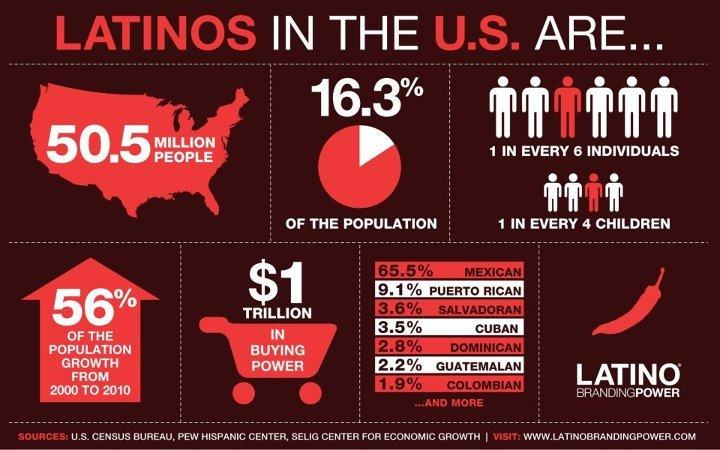Draw attention to some important aspects in this diagram. Mexican Americans constitute the majority of Latinos in the United States. 